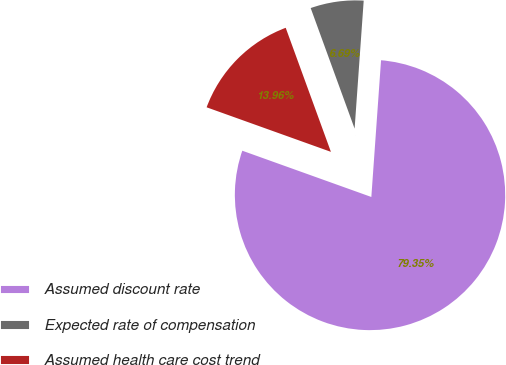Convert chart to OTSL. <chart><loc_0><loc_0><loc_500><loc_500><pie_chart><fcel>Assumed discount rate<fcel>Expected rate of compensation<fcel>Assumed health care cost trend<nl><fcel>79.35%<fcel>6.69%<fcel>13.96%<nl></chart> 